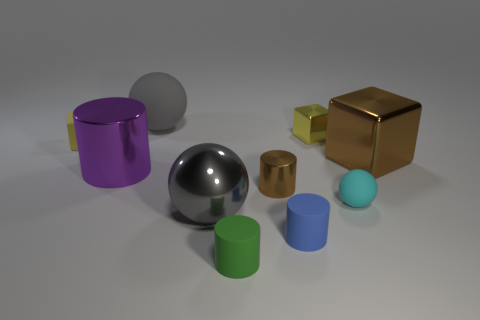What number of tiny gray rubber cubes are there?
Make the answer very short. 0. There is a matte sphere that is to the right of the small yellow shiny thing; what number of tiny things are to the left of it?
Your answer should be compact. 5. There is a small ball; is its color the same as the large sphere that is in front of the big brown metal cube?
Your answer should be compact. No. How many big brown rubber objects are the same shape as the yellow metallic thing?
Give a very brief answer. 0. What material is the gray object that is behind the large brown metallic block?
Keep it short and to the point. Rubber. There is a tiny thing to the left of the tiny green thing; does it have the same shape as the tiny brown object?
Ensure brevity in your answer.  No. Is there a blue cylinder of the same size as the rubber cube?
Your answer should be very brief. Yes. There is a tiny cyan thing; is its shape the same as the large metallic object that is in front of the tiny cyan ball?
Your answer should be very brief. Yes. What is the shape of the large object that is the same color as the big shiny ball?
Keep it short and to the point. Sphere. Is the number of brown metal objects that are left of the blue thing less than the number of big blue rubber objects?
Your response must be concise. No. 